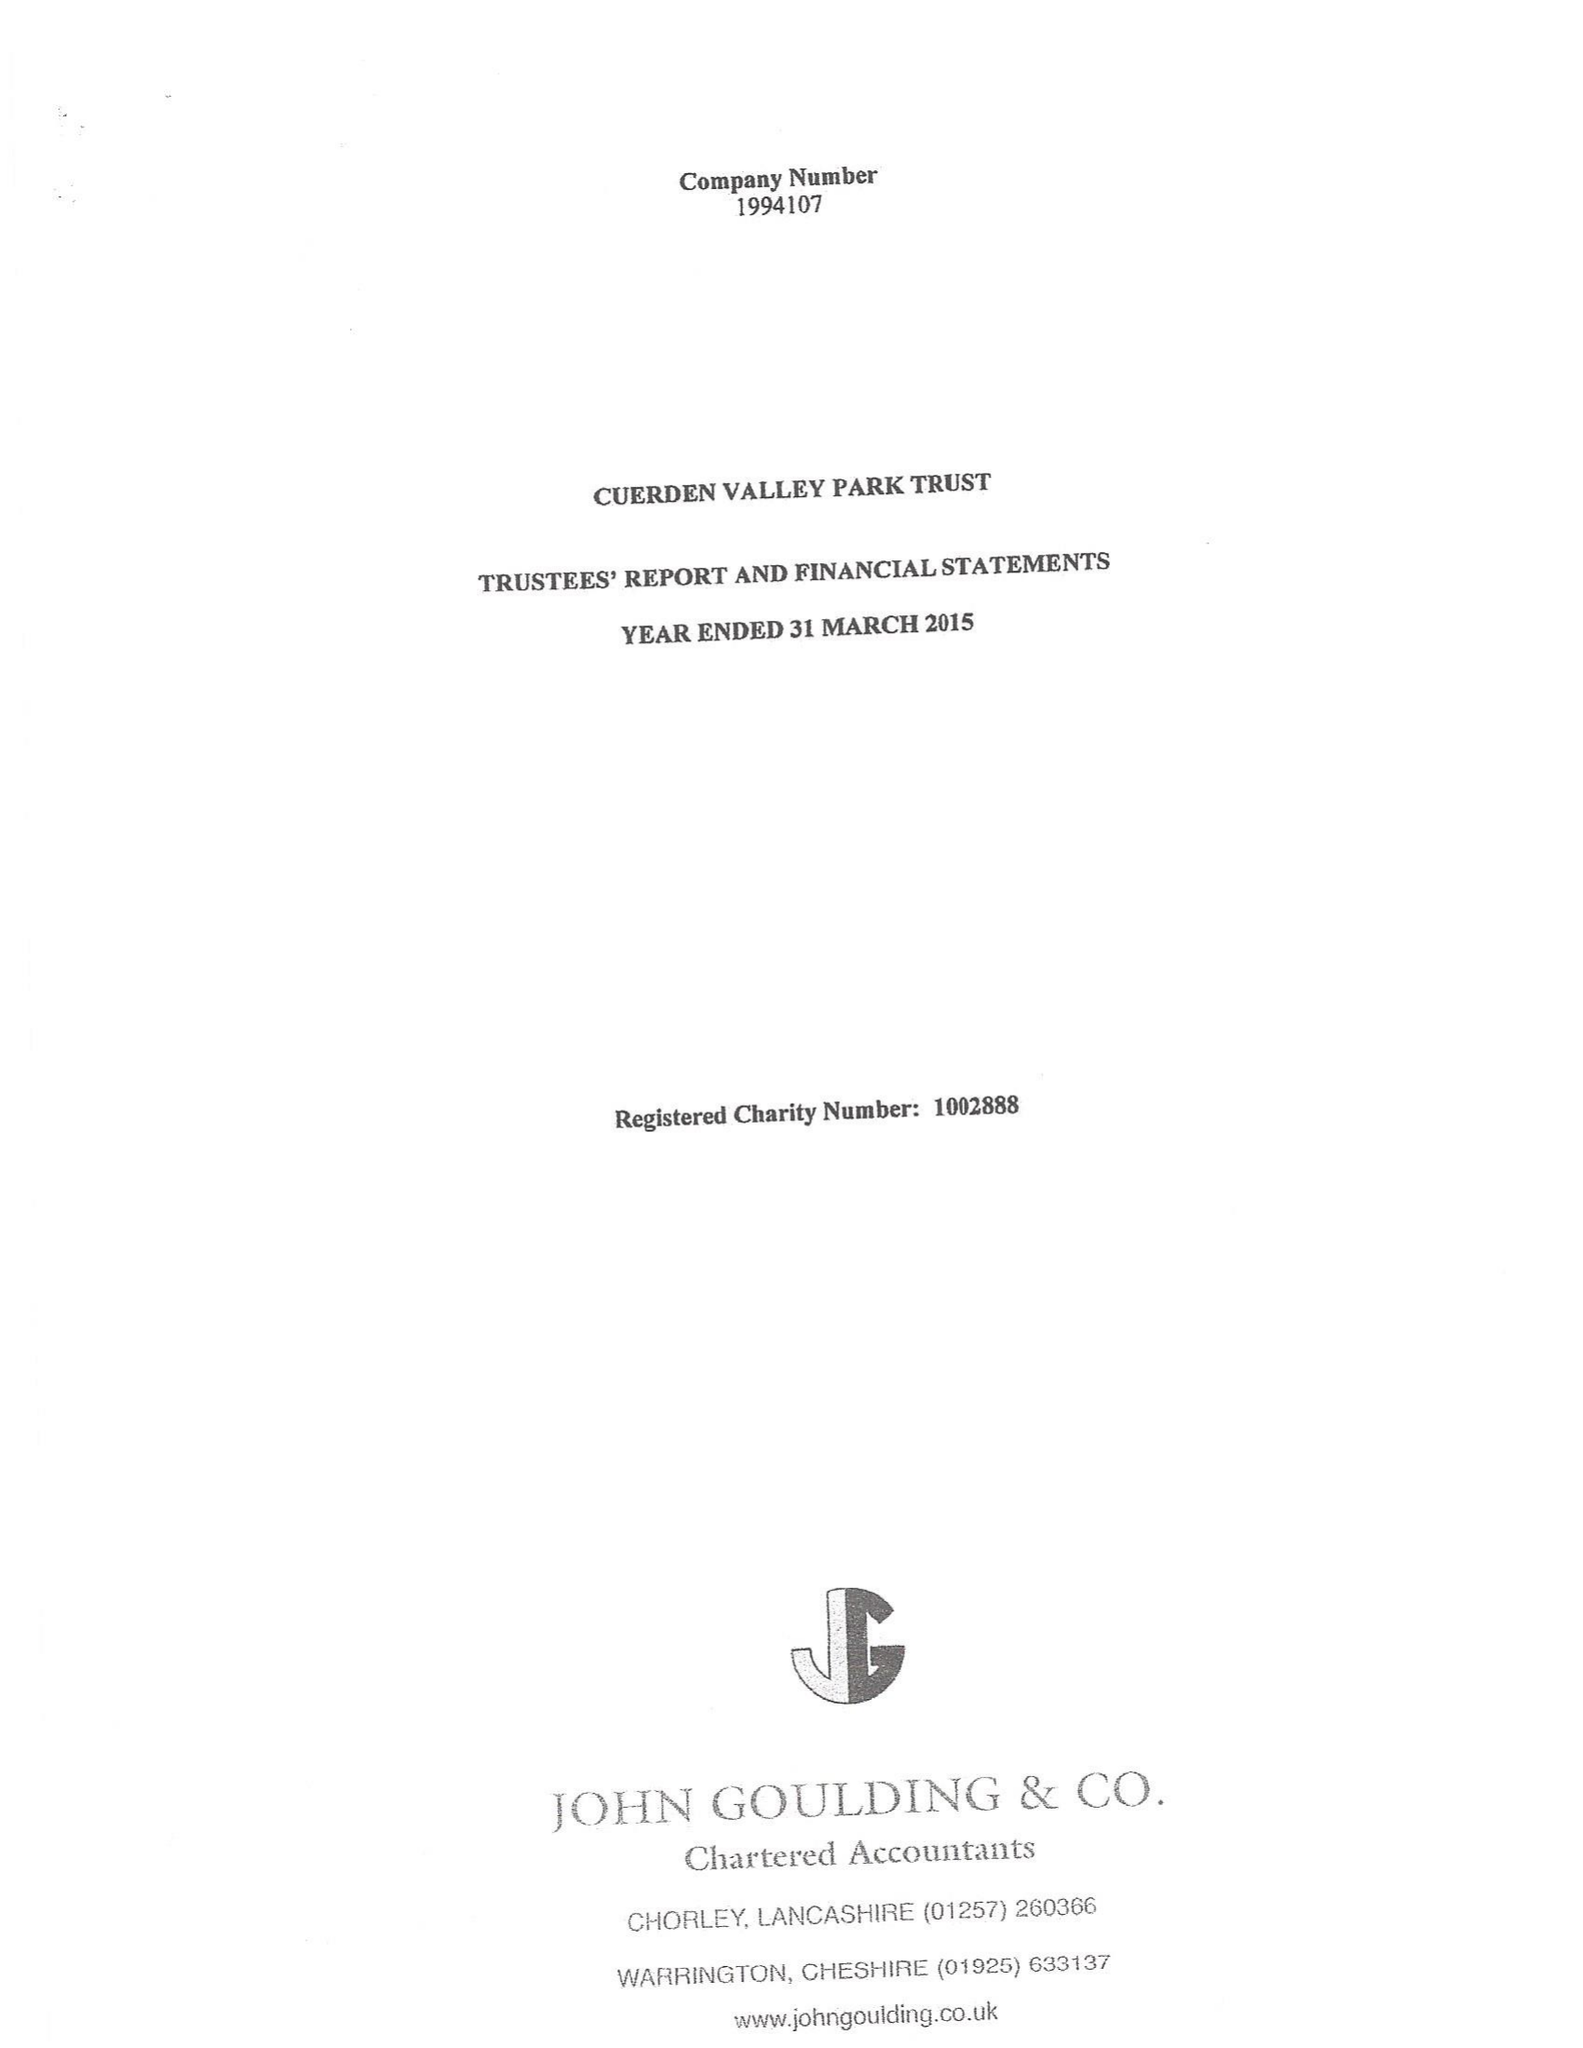What is the value for the report_date?
Answer the question using a single word or phrase. 2015-03-31 